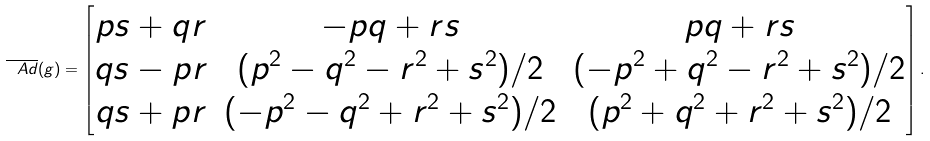Convert formula to latex. <formula><loc_0><loc_0><loc_500><loc_500>\overline { \ A d } ( g ) = \begin{bmatrix} p s + q r & - p q + r s & p q + r s \\ q s - p r & ( p ^ { 2 } - q ^ { 2 } - r ^ { 2 } + s ^ { 2 } ) / 2 & ( - p ^ { 2 } + q ^ { 2 } - r ^ { 2 } + s ^ { 2 } ) / 2 \\ q s + p r & ( - p ^ { 2 } - q ^ { 2 } + r ^ { 2 } + s ^ { 2 } ) / 2 & ( p ^ { 2 } + q ^ { 2 } + r ^ { 2 } + s ^ { 2 } ) / 2 \end{bmatrix} .</formula> 